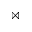<formula> <loc_0><loc_0><loc_500><loc_500>\bowtie</formula> 